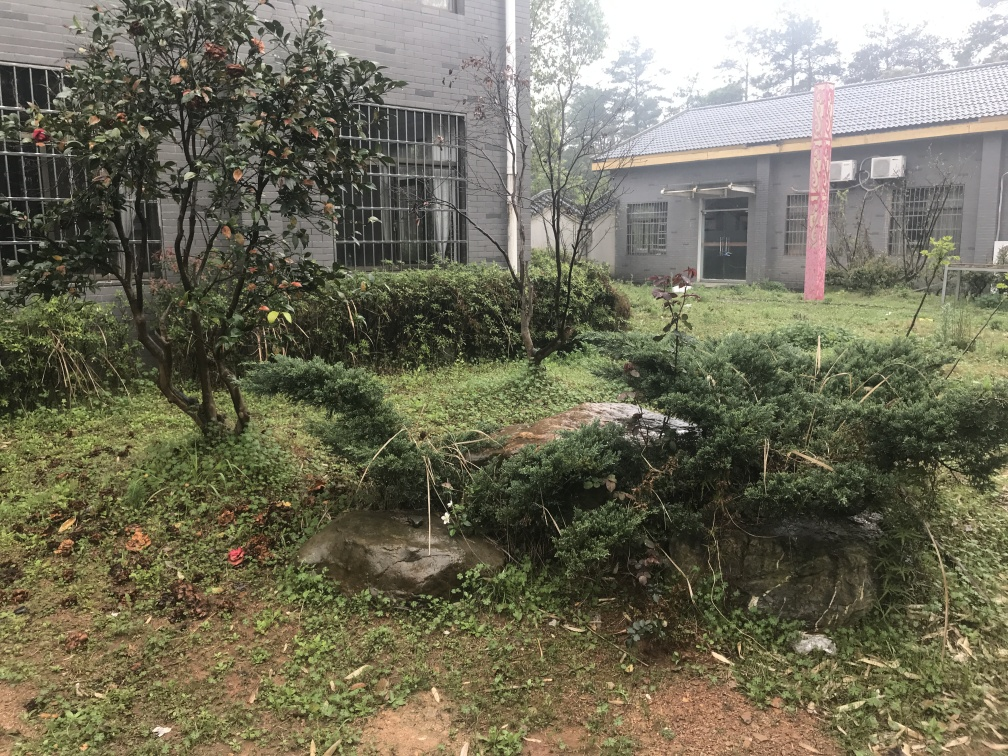Can you tell me about the features of the environment captured in this image? Certainly! The image showcases a somewhat overgrown garden area with a variety of plant life, including shrubs and possibly some wildflowers. There's a patchy grass lawn and a stone structure, which could be part of a garden feature like a pond or rockery. The backdrop includes a building with barred windows and an A/C unit, suggesting an urban setting. The atmosphere feels slightly neglected but also naturally vivacious. 